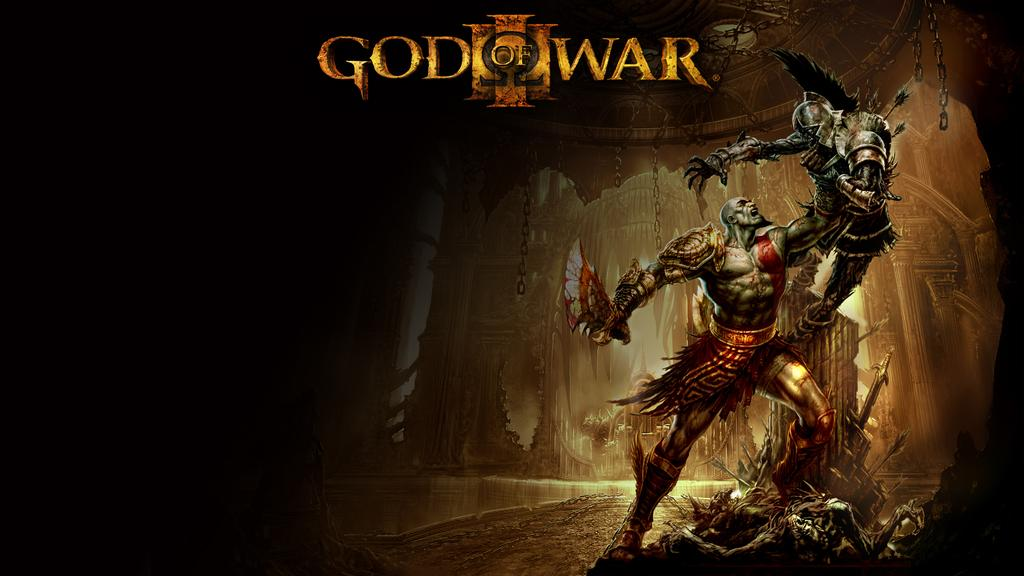<image>
Create a compact narrative representing the image presented. The cover of a video game called God Of War depicting two warriors fighting. 